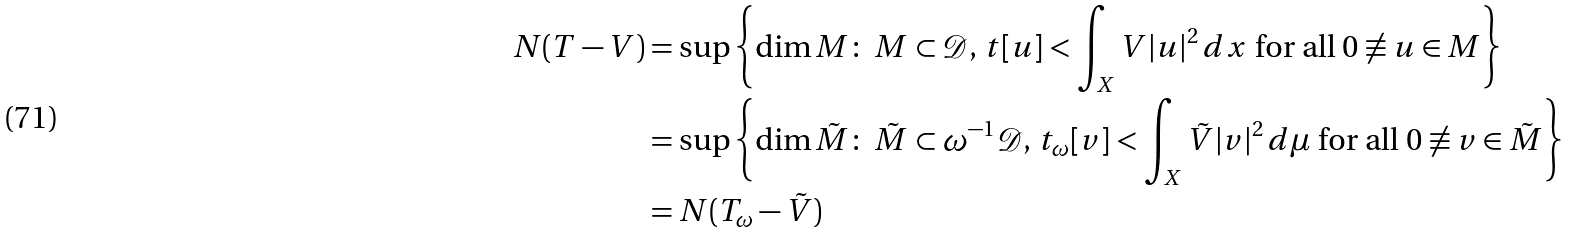Convert formula to latex. <formula><loc_0><loc_0><loc_500><loc_500>N ( T - V ) & = \sup \left \{ \dim M \colon \ M \subset \mathcal { D } , \, t [ u ] < \int _ { X } V | u | ^ { 2 } \, d x \ \text {for all} \ 0 \not \equiv u \in M \right \} \\ & = \sup \left \{ \dim \tilde { M } \colon \ \tilde { M } \subset \omega ^ { - 1 } \mathcal { D } , \, t _ { \omega } [ v ] < \int _ { X } \tilde { V } | v | ^ { 2 } \, d \mu \ \text {for all} \ 0 \not \equiv v \in \tilde { M } \right \} \\ & = N ( T _ { \omega } - \tilde { V } )</formula> 